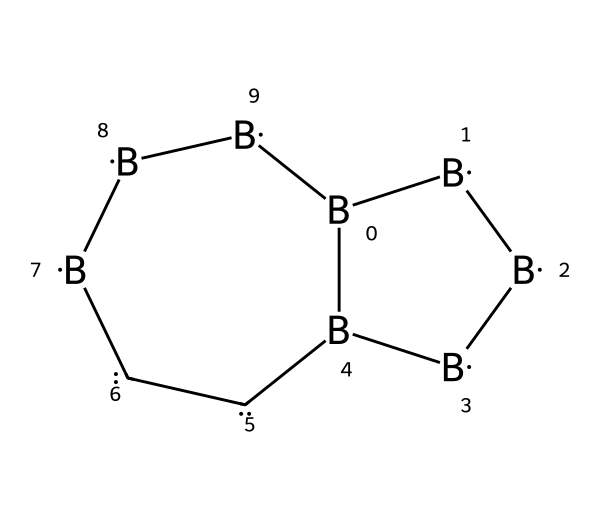How many boron atoms are in this carborane structure? The skeletal structure shows a total of five boron atoms, indicated by the letter "B" present in the SMILES notation.
Answer: five What type of bonding is primarily present in boranes like this carborane? The structure primarily exhibits covalent bonding, which is characteristic of boron and carbon interactions in borane compounds.
Answer: covalent bonding What is the connectivity of the carbon atoms in this structure? The structure shows that there are two carbon atoms that are connected to boron atoms, each contributing to the framework of the carborane.
Answer: two How does the presence of carbon atoms affect the stability of boranes? The inclusion of carbon atoms in the structure contributes to the stability of the boron framework by providing additional bonding and structural integrity, stabilizing the cluster.
Answer: stability What are the potential applications of carboranes in medicine? Carboranes have potential applications in cancer therapy due to their ability to target cancer cells and their low toxicity profile compared to conventional chemotherapeutic agents.
Answer: cancer therapy Which characteristic of carboranes allows them to be considered for drug delivery? The unique boron and carbon framework allows carboranes to be designed for the selective targeting of cancer cells, important for effective drug delivery systems.
Answer: selective targeting 